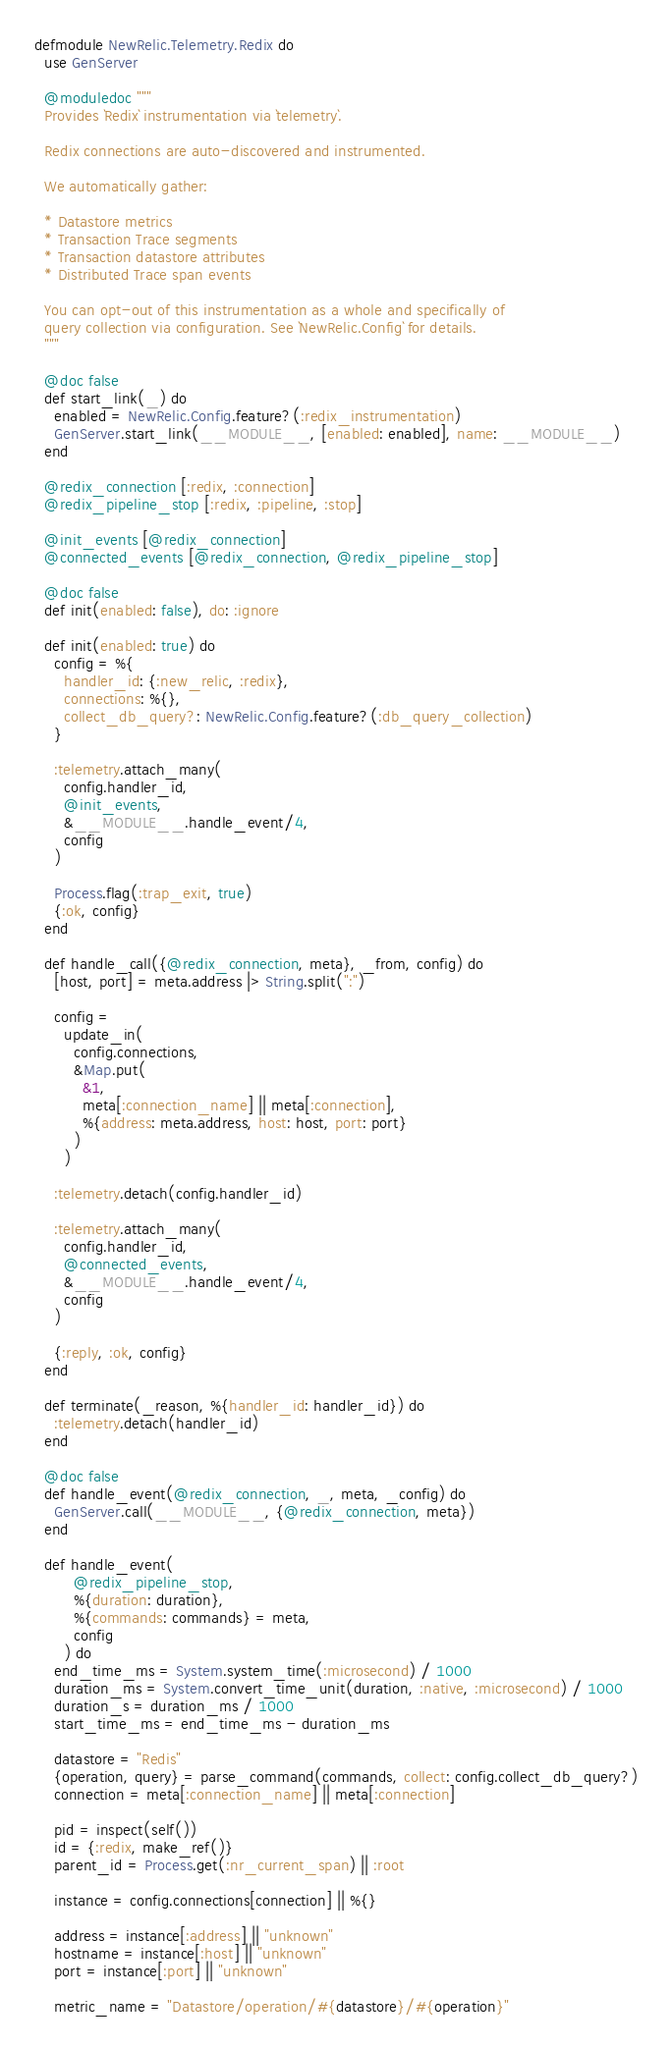Convert code to text. <code><loc_0><loc_0><loc_500><loc_500><_Elixir_>defmodule NewRelic.Telemetry.Redix do
  use GenServer

  @moduledoc """
  Provides `Redix` instrumentation via `telemetry`.

  Redix connections are auto-discovered and instrumented.

  We automatically gather:

  * Datastore metrics
  * Transaction Trace segments
  * Transaction datastore attributes
  * Distributed Trace span events

  You can opt-out of this instrumentation as a whole and specifically of
  query collection via configuration. See `NewRelic.Config` for details.
  """

  @doc false
  def start_link(_) do
    enabled = NewRelic.Config.feature?(:redix_instrumentation)
    GenServer.start_link(__MODULE__, [enabled: enabled], name: __MODULE__)
  end

  @redix_connection [:redix, :connection]
  @redix_pipeline_stop [:redix, :pipeline, :stop]

  @init_events [@redix_connection]
  @connected_events [@redix_connection, @redix_pipeline_stop]

  @doc false
  def init(enabled: false), do: :ignore

  def init(enabled: true) do
    config = %{
      handler_id: {:new_relic, :redix},
      connections: %{},
      collect_db_query?: NewRelic.Config.feature?(:db_query_collection)
    }

    :telemetry.attach_many(
      config.handler_id,
      @init_events,
      &__MODULE__.handle_event/4,
      config
    )

    Process.flag(:trap_exit, true)
    {:ok, config}
  end

  def handle_call({@redix_connection, meta}, _from, config) do
    [host, port] = meta.address |> String.split(":")

    config =
      update_in(
        config.connections,
        &Map.put(
          &1,
          meta[:connection_name] || meta[:connection],
          %{address: meta.address, host: host, port: port}
        )
      )

    :telemetry.detach(config.handler_id)

    :telemetry.attach_many(
      config.handler_id,
      @connected_events,
      &__MODULE__.handle_event/4,
      config
    )

    {:reply, :ok, config}
  end

  def terminate(_reason, %{handler_id: handler_id}) do
    :telemetry.detach(handler_id)
  end

  @doc false
  def handle_event(@redix_connection, _, meta, _config) do
    GenServer.call(__MODULE__, {@redix_connection, meta})
  end

  def handle_event(
        @redix_pipeline_stop,
        %{duration: duration},
        %{commands: commands} = meta,
        config
      ) do
    end_time_ms = System.system_time(:microsecond) / 1000
    duration_ms = System.convert_time_unit(duration, :native, :microsecond) / 1000
    duration_s = duration_ms / 1000
    start_time_ms = end_time_ms - duration_ms

    datastore = "Redis"
    {operation, query} = parse_command(commands, collect: config.collect_db_query?)
    connection = meta[:connection_name] || meta[:connection]

    pid = inspect(self())
    id = {:redix, make_ref()}
    parent_id = Process.get(:nr_current_span) || :root

    instance = config.connections[connection] || %{}

    address = instance[:address] || "unknown"
    hostname = instance[:host] || "unknown"
    port = instance[:port] || "unknown"

    metric_name = "Datastore/operation/#{datastore}/#{operation}"</code> 